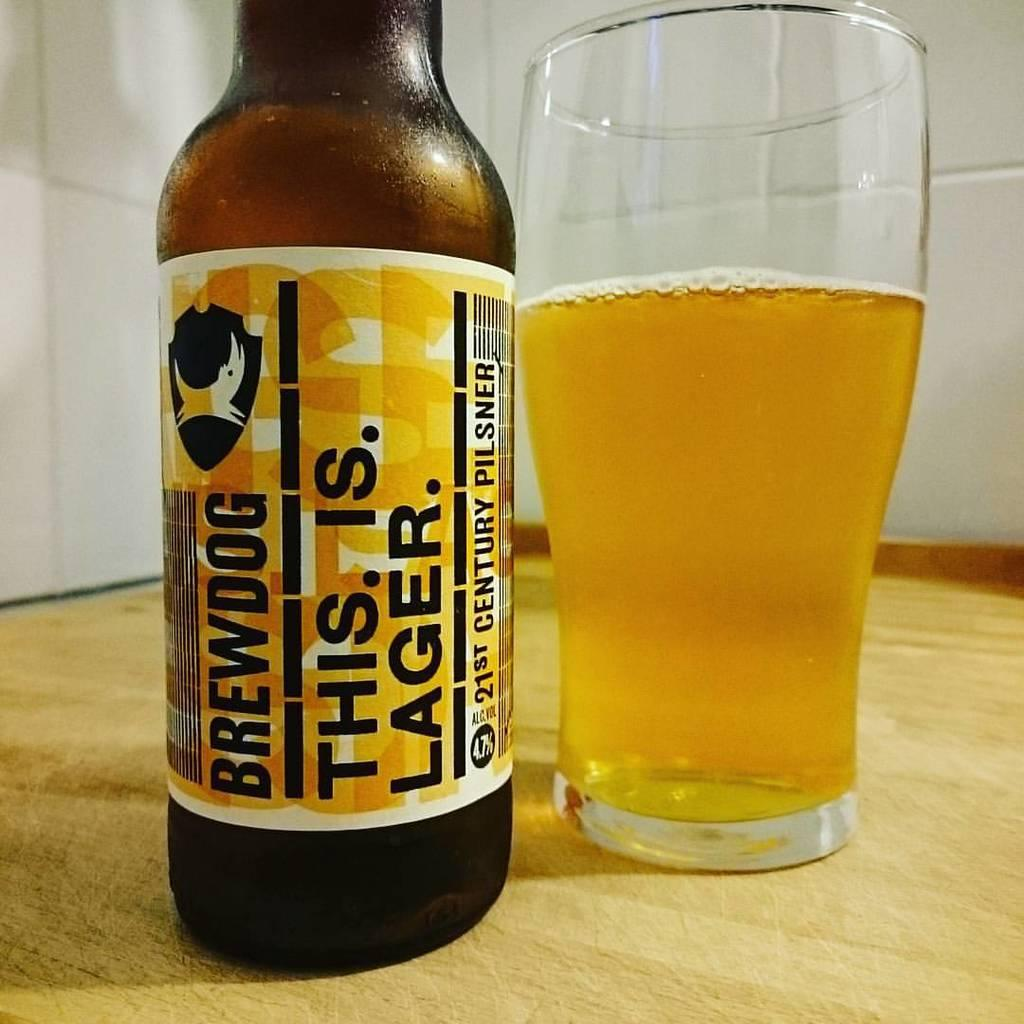<image>
Present a compact description of the photo's key features. A bottle of Brewdog beer sits next to a partially full glass. 